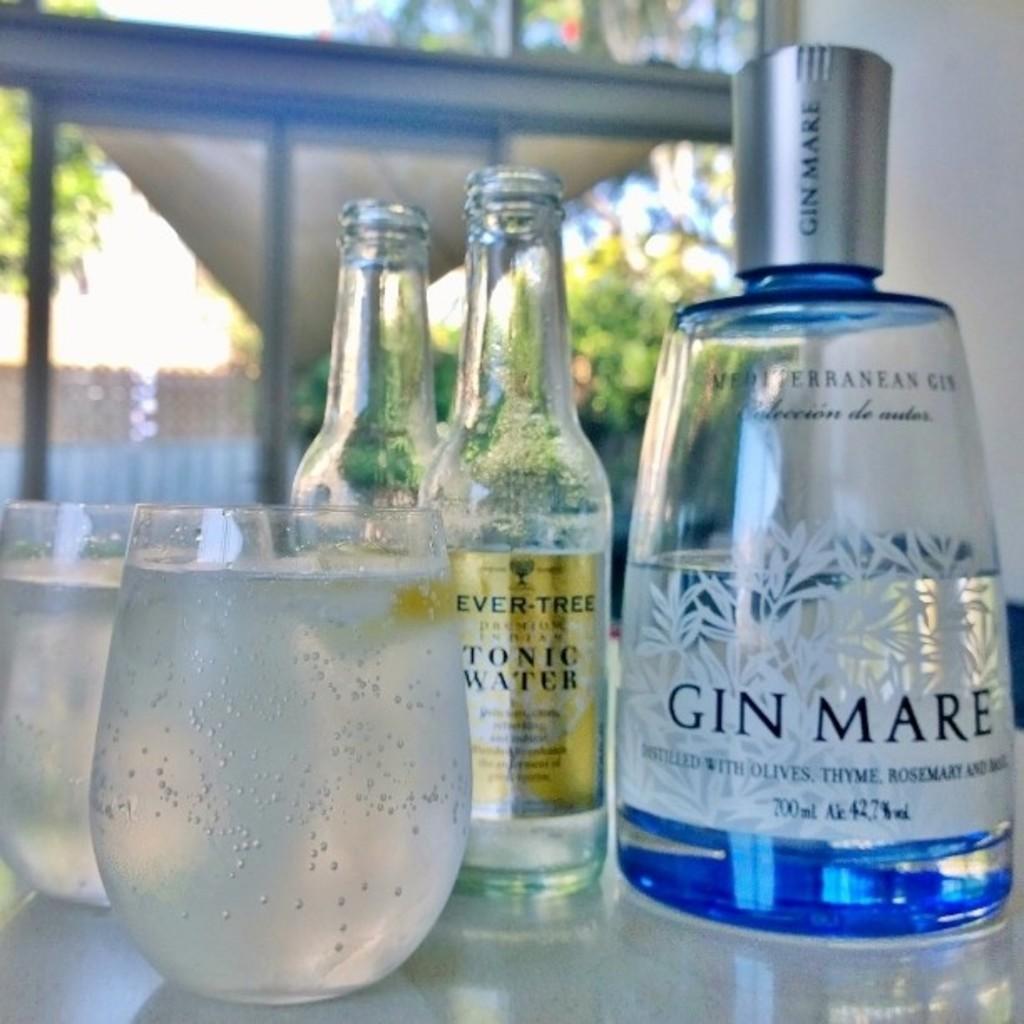What kind of tonic water is it?
Your response must be concise. Ever-tree. 